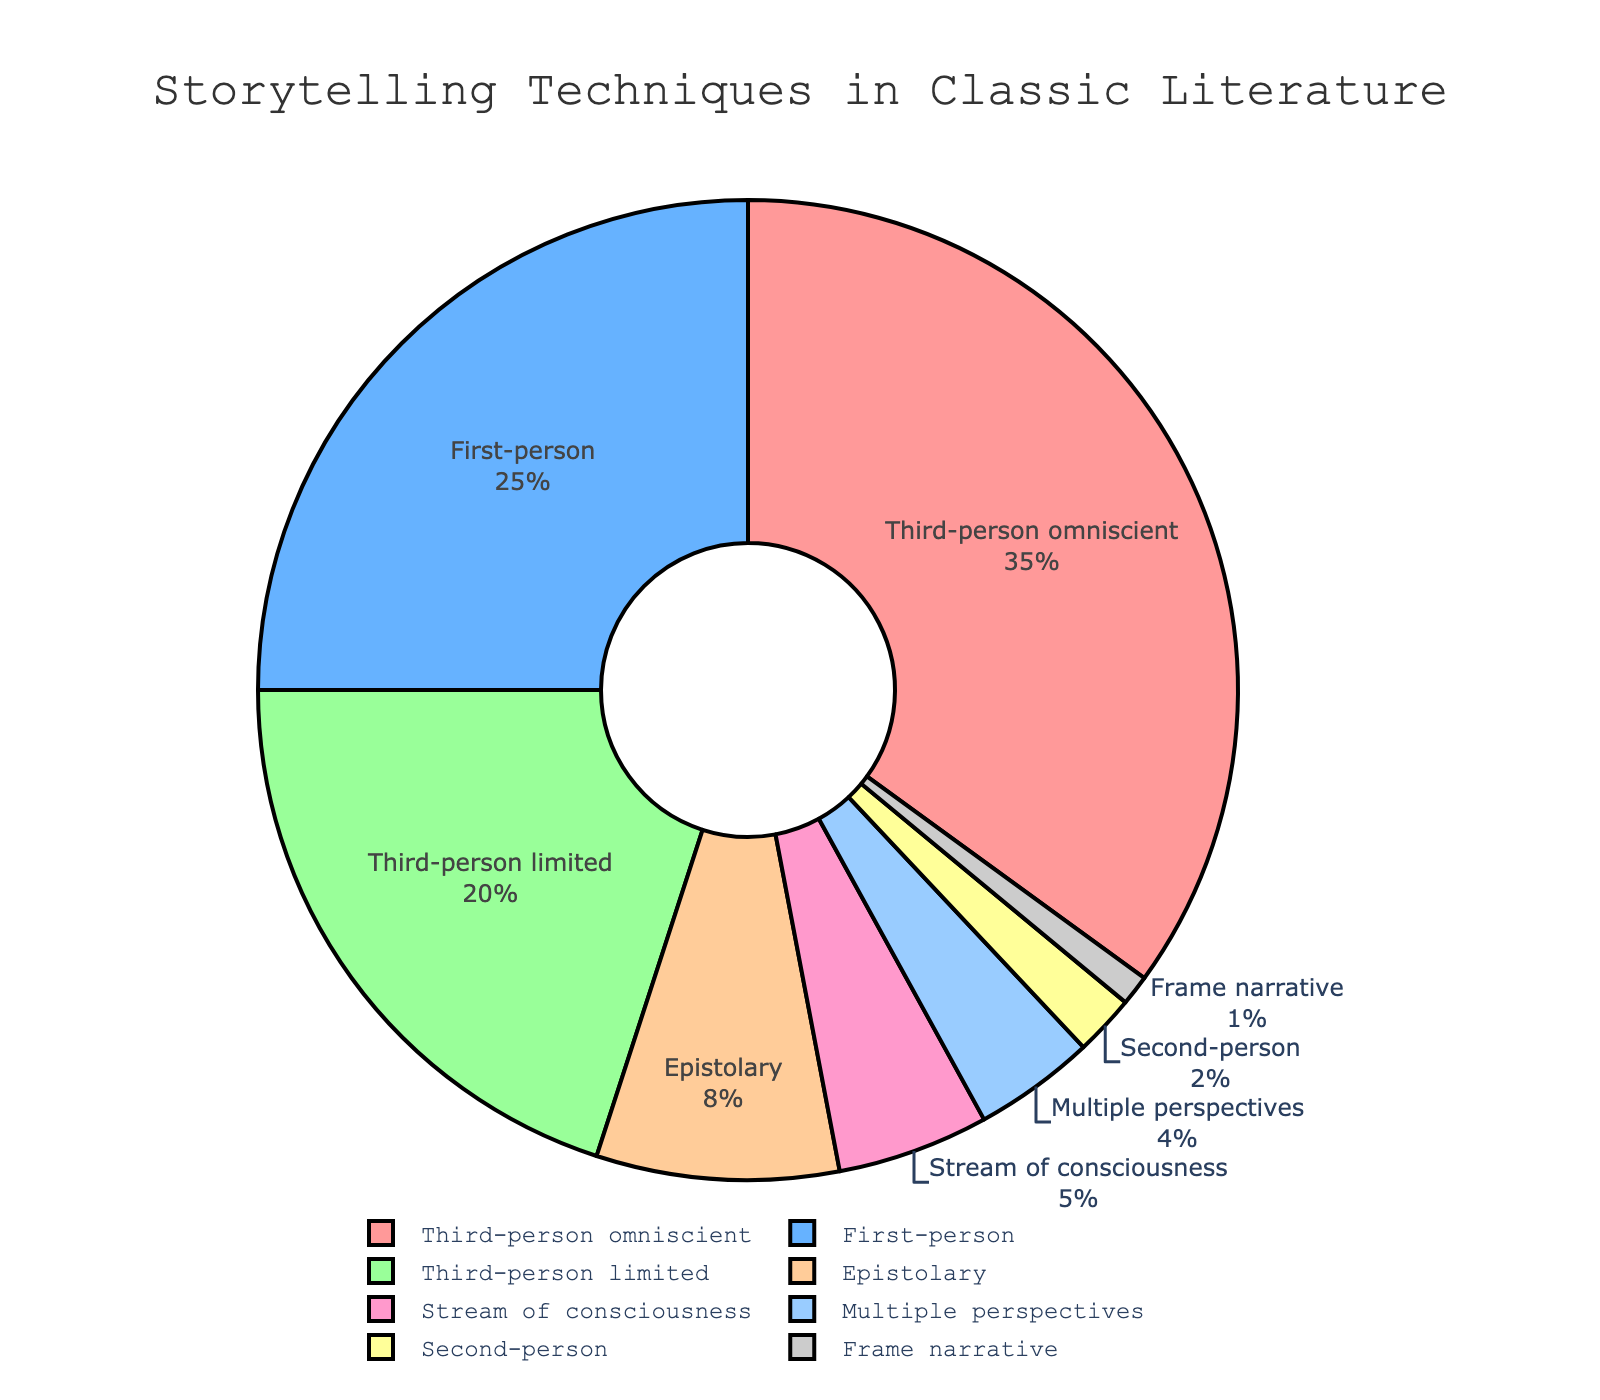What storytelling technique is used most in classic literature? To determine the most common technique, look at the segment that occupies the largest portion of the pie chart. This largest segment represents Third-person omniscient, which has the highest percentage.
Answer: Third-person omniscient What are the combined percentages of Stream of consciousness and Multiple perspectives? Add the percentages of Stream of consciousness (5%) and Multiple perspectives (4%) together. 5% + 4% = 9%
Answer: 9% Which technique is represented by the smallest segment on the pie chart? The smallest segment of the pie chart represents the technique with the lowest percentage. Frame narrative is the smallest segment with 1%.
Answer: Frame narrative How much more prevalent is First-person compared to Second-person? Subtract the percentage of Second-person (2%) from the percentage of First-person (25%) to find the difference. 25% - 2% = 23%
Answer: 23% What is the approximate percentage of techniques not using the third-person perspective? Add the percentages of all techniques that do not use the third-person perspective: First-person (25%), Epistolary (8%), Stream of consciousness (5%), Multiple perspectives (4%), Second-person (2%), Frame narrative (1%). 25% + 8% + 5% + 4% + 2% + 1% = 45%
Answer: 45% Which segment is visually represented in green? By observing the colors assigned to each segment, the green segment represents One specific technique. According to the legend or color coding, Third-person limited is usually set in green (depending on the specific color scheme provided earlier).
Answer: Third-person limited How many techniques individually constitute less than 10% of the total? Count the segments that represent less than 10%. These include Epistolary (8%), Stream of consciousness (5%), Multiple perspectives (4%), Second-person (2%), and Frame narrative (1%). There are 5 segments.
Answer: 5 What is the total percentage of all third-person techniques combined? Add the percentages of all third-person techniques: Third-person omniscient (35%) and Third-person limited (20%). 35% + 20% = 55%
Answer: 55% What technique's percentage is exactly half of the Third-person omniscient percentage? Half of Third-person omniscient (35%) is 17.5%. Third-person limited (20%) is the closest technique and, although not precisely 17.5%, it is the most reasonably matching percentage. Thus, the exact match for "half" may not correspond here. Effectively, this example should be seen as no precise matches if we focus on exact mathematics.
Answer: None 